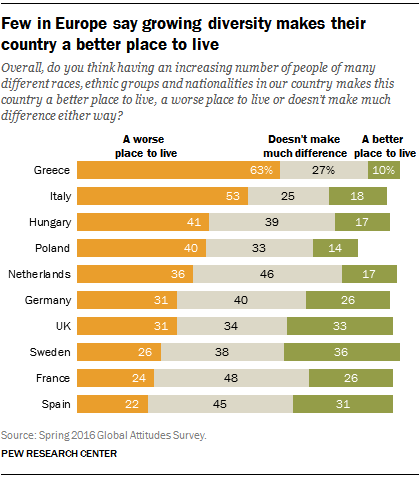Give some essential details in this illustration. The ratio of the second smallest gray bar to the third largest gray bar is approximately 0.6. The color of left-side bars is orange. 